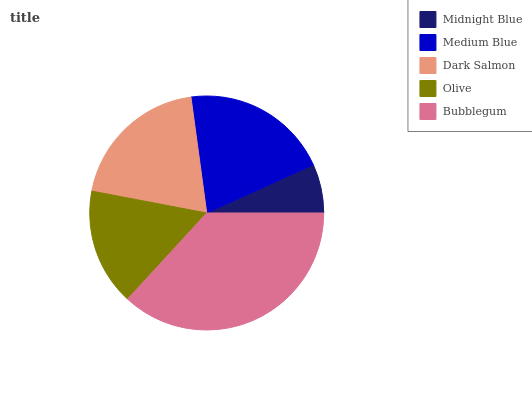Is Midnight Blue the minimum?
Answer yes or no. Yes. Is Bubblegum the maximum?
Answer yes or no. Yes. Is Medium Blue the minimum?
Answer yes or no. No. Is Medium Blue the maximum?
Answer yes or no. No. Is Medium Blue greater than Midnight Blue?
Answer yes or no. Yes. Is Midnight Blue less than Medium Blue?
Answer yes or no. Yes. Is Midnight Blue greater than Medium Blue?
Answer yes or no. No. Is Medium Blue less than Midnight Blue?
Answer yes or no. No. Is Dark Salmon the high median?
Answer yes or no. Yes. Is Dark Salmon the low median?
Answer yes or no. Yes. Is Medium Blue the high median?
Answer yes or no. No. Is Midnight Blue the low median?
Answer yes or no. No. 